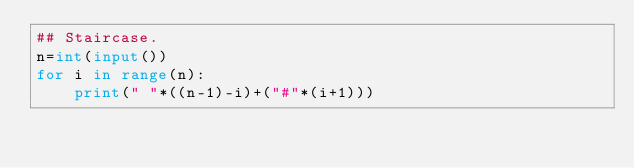Convert code to text. <code><loc_0><loc_0><loc_500><loc_500><_Python_>## Staircase.
n=int(input())
for i in range(n):
    print(" "*((n-1)-i)+("#"*(i+1)))</code> 